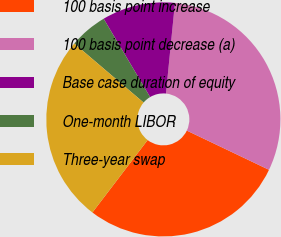<chart> <loc_0><loc_0><loc_500><loc_500><pie_chart><fcel>100 basis point increase<fcel>100 basis point decrease (a)<fcel>Base case duration of equity<fcel>One-month LIBOR<fcel>Three-year swap<nl><fcel>28.28%<fcel>30.51%<fcel>10.1%<fcel>5.25%<fcel>25.86%<nl></chart> 